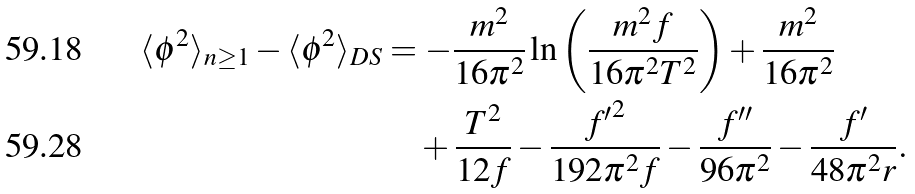<formula> <loc_0><loc_0><loc_500><loc_500>\langle \phi ^ { 2 } \rangle _ { n \geq 1 } - \langle \phi ^ { 2 } \rangle _ { D S } & = - \frac { m ^ { 2 } } { 1 6 \pi ^ { 2 } } \ln \left ( \frac { m ^ { 2 } f } { 1 6 \pi ^ { 2 } T ^ { 2 } } \right ) + \frac { m ^ { 2 } } { 1 6 \pi ^ { 2 } } \\ & \quad + \frac { T ^ { 2 } } { 1 2 f } - \frac { { f ^ { \prime } } ^ { 2 } } { 1 9 2 \pi ^ { 2 } f } - \frac { f ^ { \prime \prime } } { 9 6 \pi ^ { 2 } } - \frac { f ^ { \prime } } { 4 8 \pi ^ { 2 } r } .</formula> 